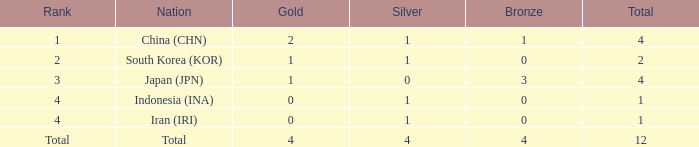How many silver medals does the country with less than one gold and a total of fewer than one have? 0.0. Give me the full table as a dictionary. {'header': ['Rank', 'Nation', 'Gold', 'Silver', 'Bronze', 'Total'], 'rows': [['1', 'China (CHN)', '2', '1', '1', '4'], ['2', 'South Korea (KOR)', '1', '1', '0', '2'], ['3', 'Japan (JPN)', '1', '0', '3', '4'], ['4', 'Indonesia (INA)', '0', '1', '0', '1'], ['4', 'Iran (IRI)', '0', '1', '0', '1'], ['Total', 'Total', '4', '4', '4', '12']]} 